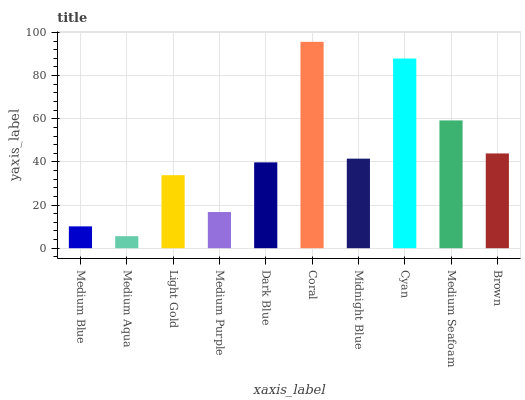Is Medium Aqua the minimum?
Answer yes or no. Yes. Is Coral the maximum?
Answer yes or no. Yes. Is Light Gold the minimum?
Answer yes or no. No. Is Light Gold the maximum?
Answer yes or no. No. Is Light Gold greater than Medium Aqua?
Answer yes or no. Yes. Is Medium Aqua less than Light Gold?
Answer yes or no. Yes. Is Medium Aqua greater than Light Gold?
Answer yes or no. No. Is Light Gold less than Medium Aqua?
Answer yes or no. No. Is Midnight Blue the high median?
Answer yes or no. Yes. Is Dark Blue the low median?
Answer yes or no. Yes. Is Cyan the high median?
Answer yes or no. No. Is Midnight Blue the low median?
Answer yes or no. No. 